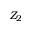Convert formula to latex. <formula><loc_0><loc_0><loc_500><loc_500>Z _ { 2 }</formula> 